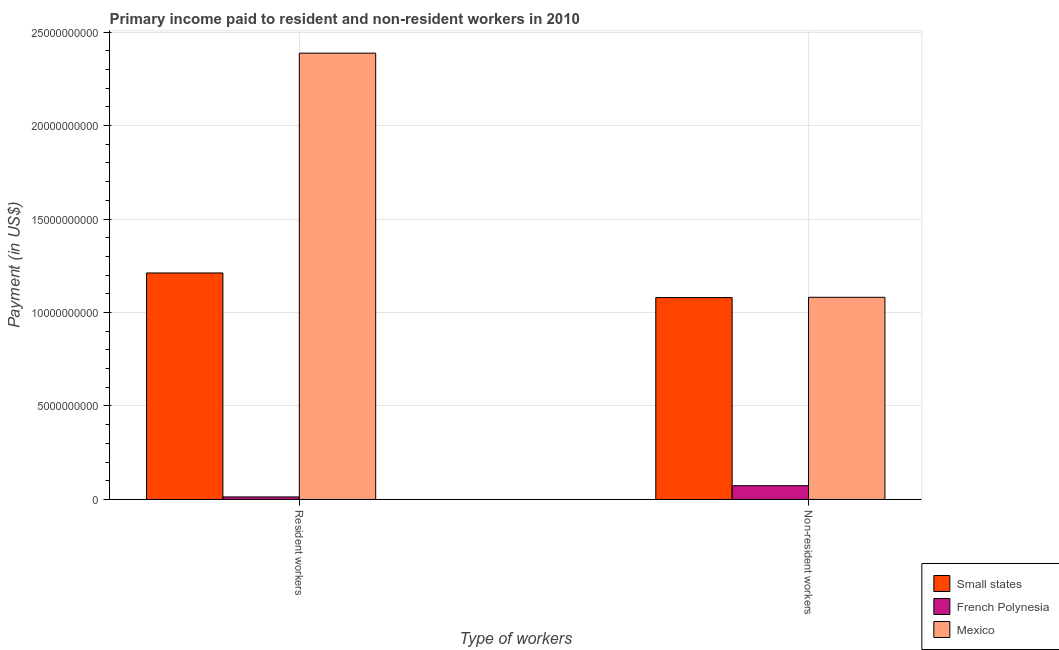Are the number of bars per tick equal to the number of legend labels?
Make the answer very short. Yes. How many bars are there on the 2nd tick from the left?
Provide a short and direct response. 3. What is the label of the 2nd group of bars from the left?
Offer a terse response. Non-resident workers. What is the payment made to non-resident workers in Small states?
Your answer should be compact. 1.08e+1. Across all countries, what is the maximum payment made to resident workers?
Offer a very short reply. 2.39e+1. Across all countries, what is the minimum payment made to non-resident workers?
Your answer should be very brief. 7.36e+08. In which country was the payment made to non-resident workers minimum?
Make the answer very short. French Polynesia. What is the total payment made to resident workers in the graph?
Keep it short and to the point. 3.61e+1. What is the difference between the payment made to resident workers in Small states and that in Mexico?
Provide a succinct answer. -1.18e+1. What is the difference between the payment made to non-resident workers in Small states and the payment made to resident workers in French Polynesia?
Your response must be concise. 1.07e+1. What is the average payment made to non-resident workers per country?
Provide a short and direct response. 7.45e+09. What is the difference between the payment made to resident workers and payment made to non-resident workers in French Polynesia?
Your response must be concise. -6.01e+08. What is the ratio of the payment made to resident workers in French Polynesia to that in Small states?
Your response must be concise. 0.01. What does the 3rd bar from the left in Resident workers represents?
Offer a terse response. Mexico. What does the 2nd bar from the right in Resident workers represents?
Give a very brief answer. French Polynesia. Are all the bars in the graph horizontal?
Give a very brief answer. No. How many countries are there in the graph?
Keep it short and to the point. 3. Are the values on the major ticks of Y-axis written in scientific E-notation?
Provide a short and direct response. No. Does the graph contain grids?
Offer a very short reply. Yes. Where does the legend appear in the graph?
Provide a short and direct response. Bottom right. How many legend labels are there?
Offer a terse response. 3. What is the title of the graph?
Provide a succinct answer. Primary income paid to resident and non-resident workers in 2010. What is the label or title of the X-axis?
Keep it short and to the point. Type of workers. What is the label or title of the Y-axis?
Offer a terse response. Payment (in US$). What is the Payment (in US$) in Small states in Resident workers?
Provide a succinct answer. 1.21e+1. What is the Payment (in US$) of French Polynesia in Resident workers?
Keep it short and to the point. 1.35e+08. What is the Payment (in US$) in Mexico in Resident workers?
Offer a terse response. 2.39e+1. What is the Payment (in US$) in Small states in Non-resident workers?
Ensure brevity in your answer.  1.08e+1. What is the Payment (in US$) of French Polynesia in Non-resident workers?
Offer a terse response. 7.36e+08. What is the Payment (in US$) of Mexico in Non-resident workers?
Give a very brief answer. 1.08e+1. Across all Type of workers, what is the maximum Payment (in US$) in Small states?
Your answer should be very brief. 1.21e+1. Across all Type of workers, what is the maximum Payment (in US$) of French Polynesia?
Offer a very short reply. 7.36e+08. Across all Type of workers, what is the maximum Payment (in US$) of Mexico?
Keep it short and to the point. 2.39e+1. Across all Type of workers, what is the minimum Payment (in US$) of Small states?
Provide a short and direct response. 1.08e+1. Across all Type of workers, what is the minimum Payment (in US$) of French Polynesia?
Keep it short and to the point. 1.35e+08. Across all Type of workers, what is the minimum Payment (in US$) in Mexico?
Give a very brief answer. 1.08e+1. What is the total Payment (in US$) in Small states in the graph?
Provide a succinct answer. 2.29e+1. What is the total Payment (in US$) in French Polynesia in the graph?
Provide a short and direct response. 8.71e+08. What is the total Payment (in US$) in Mexico in the graph?
Offer a terse response. 3.47e+1. What is the difference between the Payment (in US$) of Small states in Resident workers and that in Non-resident workers?
Provide a short and direct response. 1.31e+09. What is the difference between the Payment (in US$) of French Polynesia in Resident workers and that in Non-resident workers?
Give a very brief answer. -6.01e+08. What is the difference between the Payment (in US$) of Mexico in Resident workers and that in Non-resident workers?
Make the answer very short. 1.31e+1. What is the difference between the Payment (in US$) of Small states in Resident workers and the Payment (in US$) of French Polynesia in Non-resident workers?
Ensure brevity in your answer.  1.14e+1. What is the difference between the Payment (in US$) in Small states in Resident workers and the Payment (in US$) in Mexico in Non-resident workers?
Your response must be concise. 1.30e+09. What is the difference between the Payment (in US$) of French Polynesia in Resident workers and the Payment (in US$) of Mexico in Non-resident workers?
Your answer should be compact. -1.07e+1. What is the average Payment (in US$) in Small states per Type of workers?
Provide a short and direct response. 1.15e+1. What is the average Payment (in US$) in French Polynesia per Type of workers?
Provide a succinct answer. 4.35e+08. What is the average Payment (in US$) in Mexico per Type of workers?
Keep it short and to the point. 1.73e+1. What is the difference between the Payment (in US$) of Small states and Payment (in US$) of French Polynesia in Resident workers?
Provide a short and direct response. 1.20e+1. What is the difference between the Payment (in US$) of Small states and Payment (in US$) of Mexico in Resident workers?
Offer a very short reply. -1.18e+1. What is the difference between the Payment (in US$) in French Polynesia and Payment (in US$) in Mexico in Resident workers?
Your answer should be compact. -2.37e+1. What is the difference between the Payment (in US$) in Small states and Payment (in US$) in French Polynesia in Non-resident workers?
Your answer should be compact. 1.01e+1. What is the difference between the Payment (in US$) of Small states and Payment (in US$) of Mexico in Non-resident workers?
Ensure brevity in your answer.  -1.27e+07. What is the difference between the Payment (in US$) of French Polynesia and Payment (in US$) of Mexico in Non-resident workers?
Keep it short and to the point. -1.01e+1. What is the ratio of the Payment (in US$) of Small states in Resident workers to that in Non-resident workers?
Provide a succinct answer. 1.12. What is the ratio of the Payment (in US$) in French Polynesia in Resident workers to that in Non-resident workers?
Your answer should be compact. 0.18. What is the ratio of the Payment (in US$) of Mexico in Resident workers to that in Non-resident workers?
Make the answer very short. 2.21. What is the difference between the highest and the second highest Payment (in US$) in Small states?
Provide a succinct answer. 1.31e+09. What is the difference between the highest and the second highest Payment (in US$) of French Polynesia?
Offer a terse response. 6.01e+08. What is the difference between the highest and the second highest Payment (in US$) in Mexico?
Give a very brief answer. 1.31e+1. What is the difference between the highest and the lowest Payment (in US$) in Small states?
Ensure brevity in your answer.  1.31e+09. What is the difference between the highest and the lowest Payment (in US$) of French Polynesia?
Provide a succinct answer. 6.01e+08. What is the difference between the highest and the lowest Payment (in US$) of Mexico?
Provide a short and direct response. 1.31e+1. 